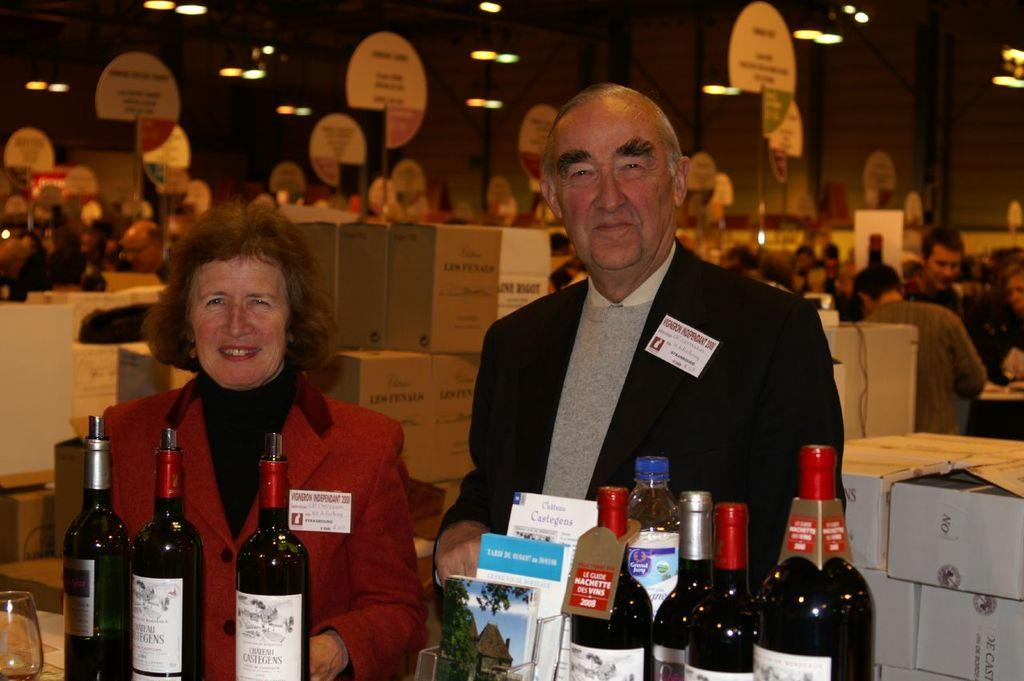Who are the people in the image? There is a woman and a man in the image. What are the expressions on their faces? Both the woman and the man are smiling. What can be seen in front of them? There are many wine bottles in front of them. What type of flesh can be seen on the woman's nose in the image? There is no flesh visible on the woman's nose in the image, and the topic of flesh is not relevant to the image. 